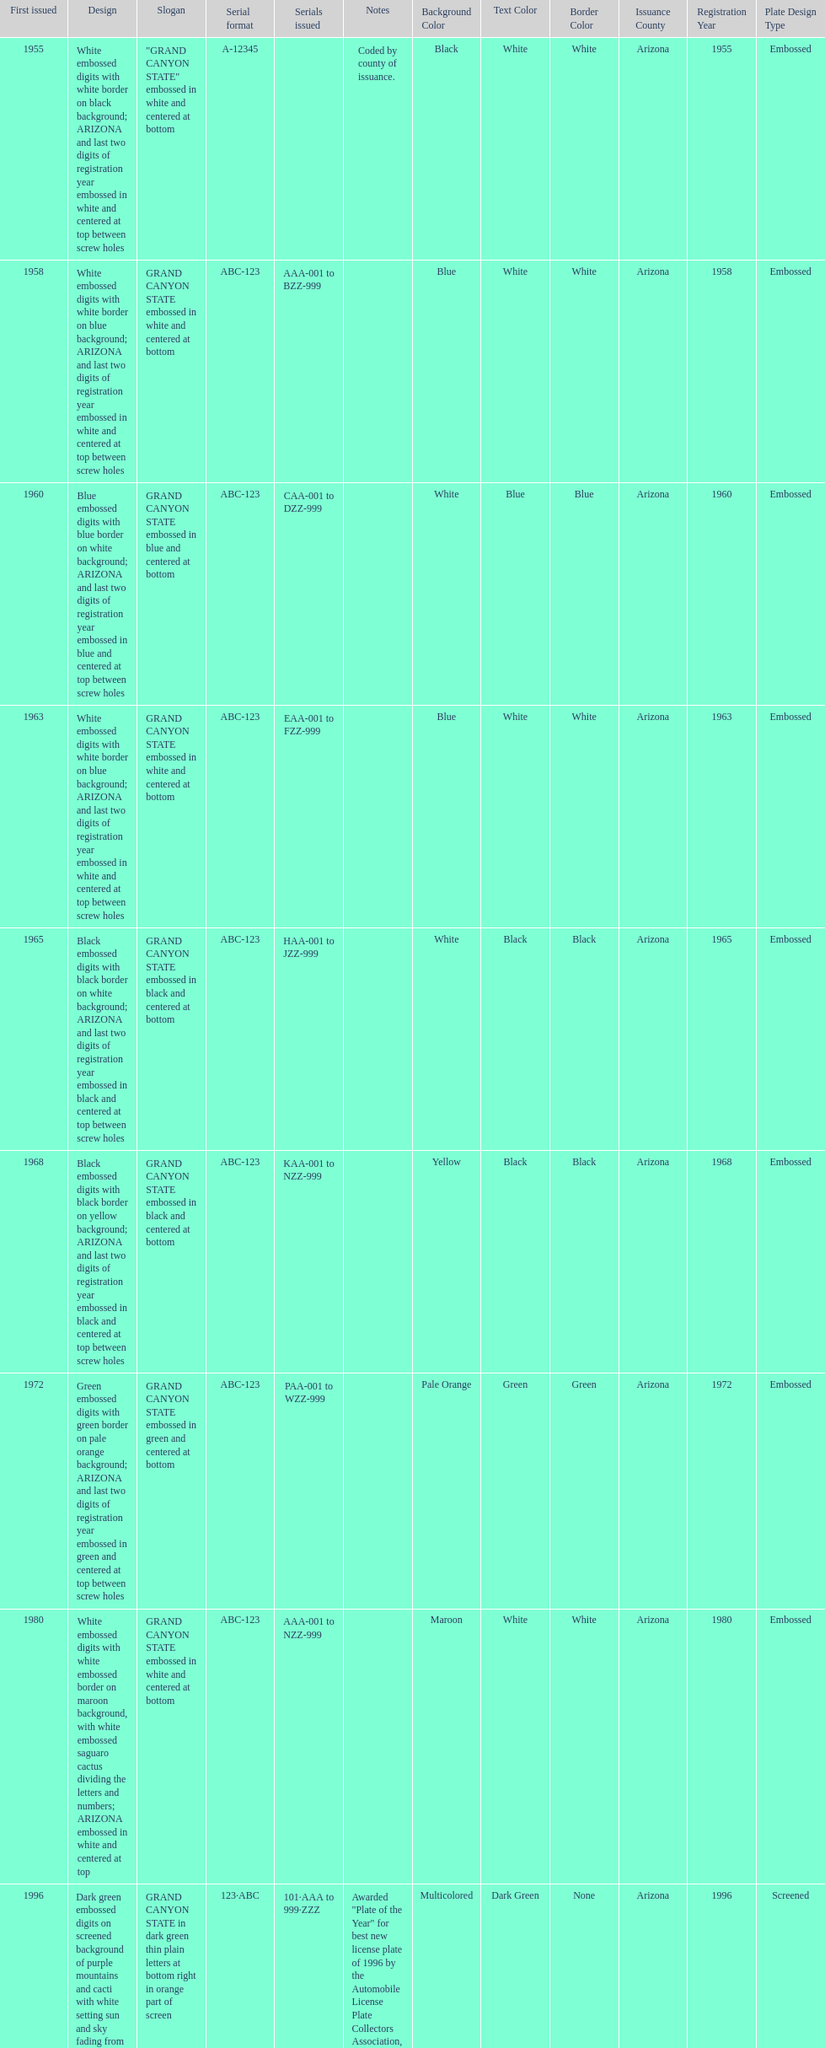What is the average serial format of the arizona license plates? ABC-123. 